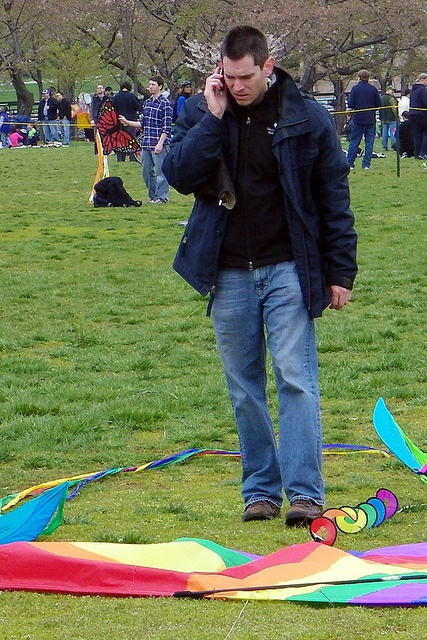Describe the objects in this image and their specific colors. I can see people in gray, black, navy, and blue tones, kite in gray, khaki, lightyellow, brown, and salmon tones, people in gray, navy, and black tones, people in gray, navy, black, and darkblue tones, and people in gray, black, navy, and darkgray tones in this image. 